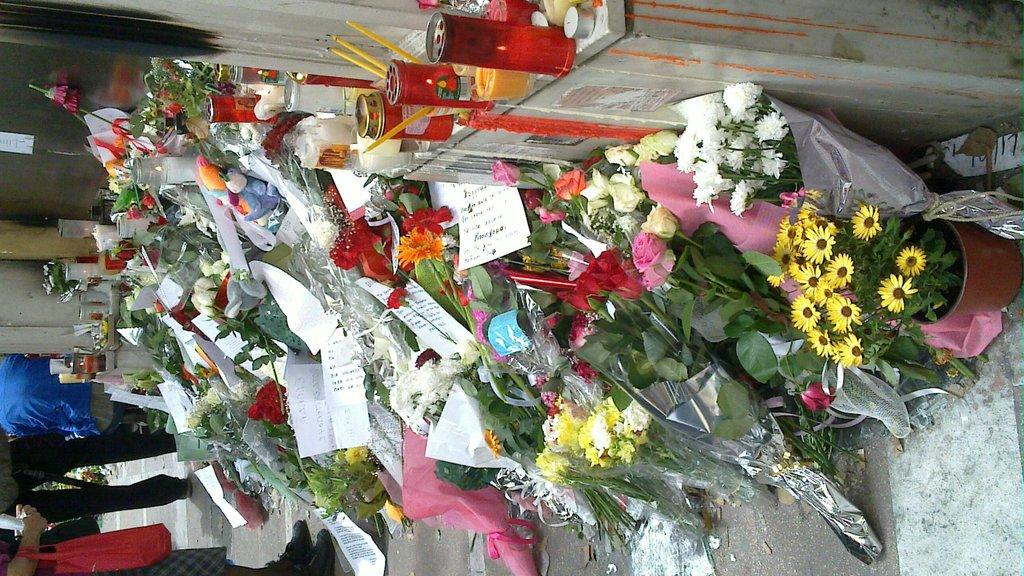What type of objects can be seen in the image? There are bouquets, candles, papers, and a poster on the wall in the image. Are there any people present in the image? Yes, there are people in the image. Can you describe one person's attire? One person is wearing a bag. What might the papers be used for in the image? The papers could be used for various purposes, such as writing or drawing. What type of railway is visible in the image? There is no railway present in the image. What color is the spark coming from the suit in the image? There is no suit or spark present in the image. 